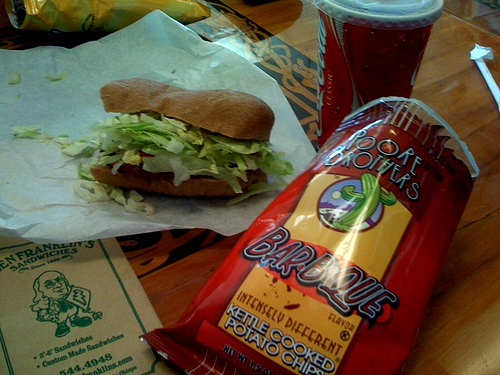What kind of sandwich is shown in the image? The sandwich in the image appears to be a sub sandwich with lettuce and possibly other fillings, although the exact ingredients cannot be determined from this angle. 